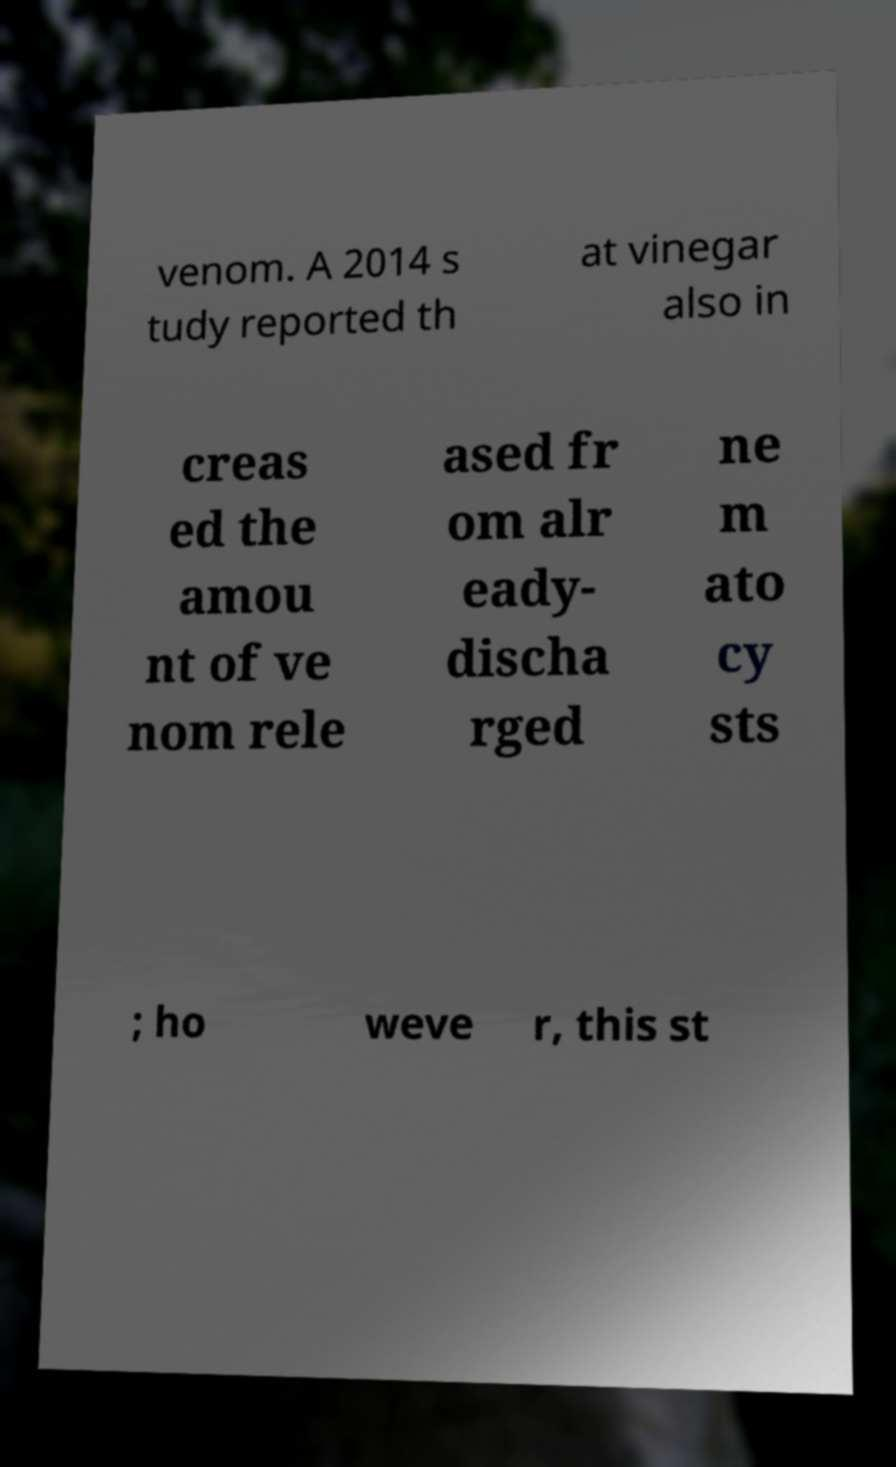Can you read and provide the text displayed in the image?This photo seems to have some interesting text. Can you extract and type it out for me? venom. A 2014 s tudy reported th at vinegar also in creas ed the amou nt of ve nom rele ased fr om alr eady- discha rged ne m ato cy sts ; ho weve r, this st 